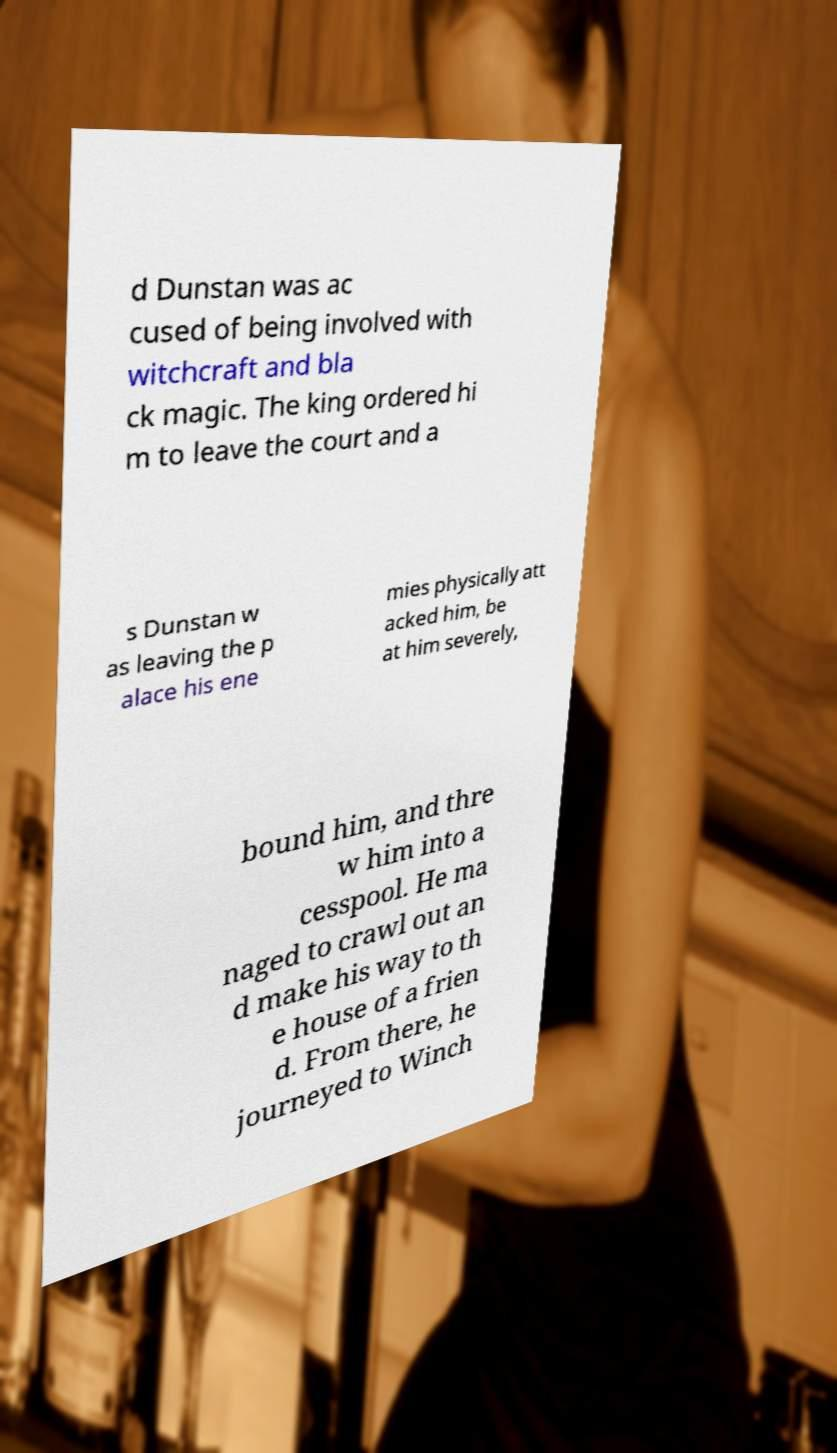Could you assist in decoding the text presented in this image and type it out clearly? d Dunstan was ac cused of being involved with witchcraft and bla ck magic. The king ordered hi m to leave the court and a s Dunstan w as leaving the p alace his ene mies physically att acked him, be at him severely, bound him, and thre w him into a cesspool. He ma naged to crawl out an d make his way to th e house of a frien d. From there, he journeyed to Winch 